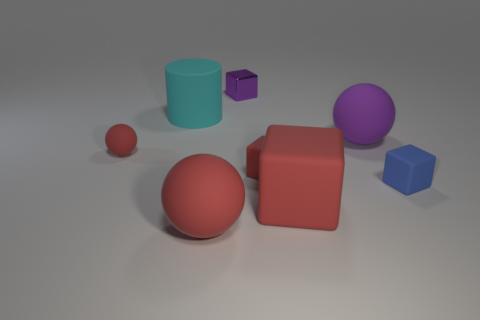Subtract 1 cubes. How many cubes are left? 3 Add 1 metal objects. How many objects exist? 9 Subtract all cylinders. How many objects are left? 7 Subtract all purple matte spheres. Subtract all tiny red shiny cylinders. How many objects are left? 7 Add 7 cylinders. How many cylinders are left? 8 Add 3 large red balls. How many large red balls exist? 4 Subtract 0 brown blocks. How many objects are left? 8 